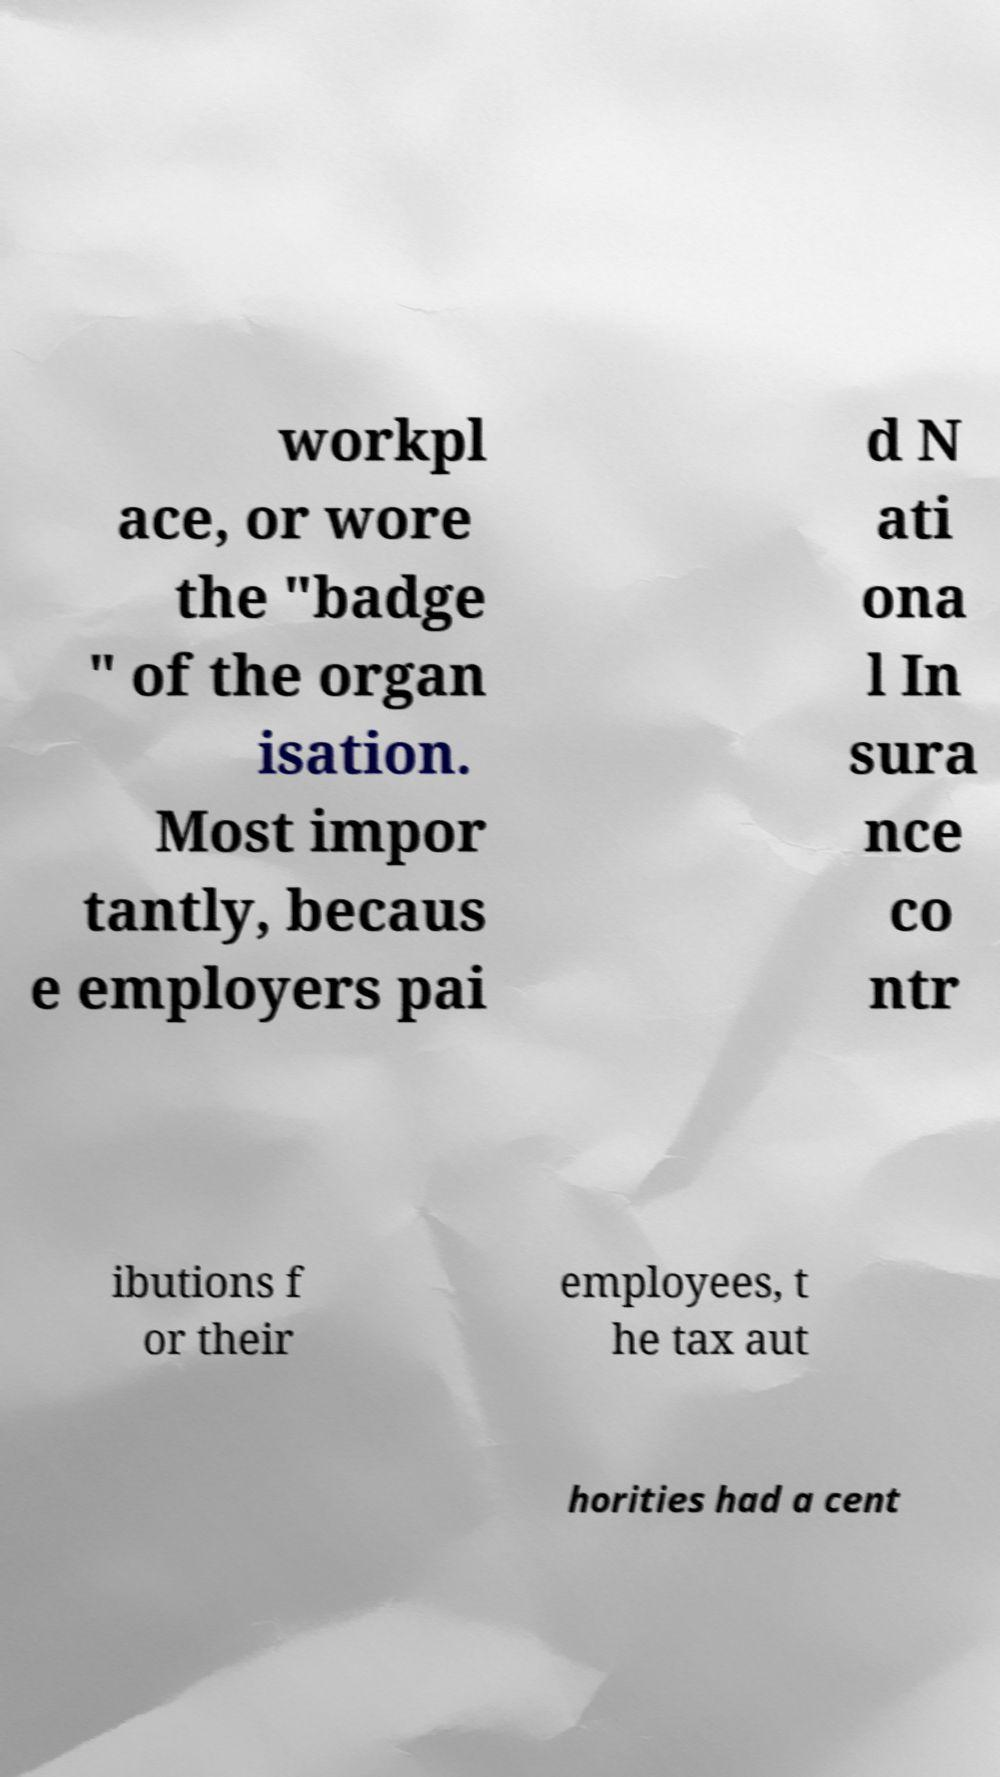What messages or text are displayed in this image? I need them in a readable, typed format. workpl ace, or wore the "badge " of the organ isation. Most impor tantly, becaus e employers pai d N ati ona l In sura nce co ntr ibutions f or their employees, t he tax aut horities had a cent 